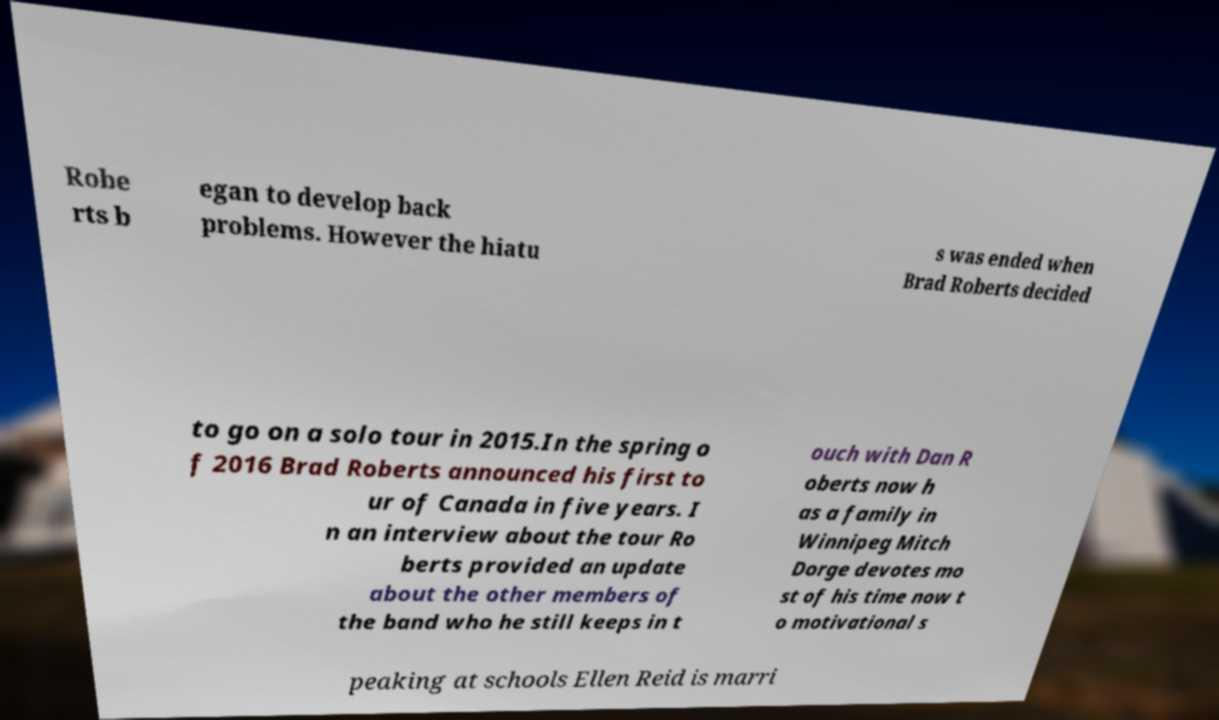For documentation purposes, I need the text within this image transcribed. Could you provide that? Robe rts b egan to develop back problems. However the hiatu s was ended when Brad Roberts decided to go on a solo tour in 2015.In the spring o f 2016 Brad Roberts announced his first to ur of Canada in five years. I n an interview about the tour Ro berts provided an update about the other members of the band who he still keeps in t ouch with Dan R oberts now h as a family in Winnipeg Mitch Dorge devotes mo st of his time now t o motivational s peaking at schools Ellen Reid is marri 